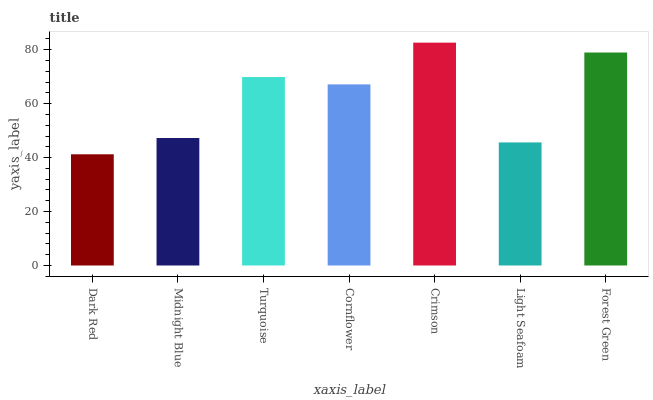Is Dark Red the minimum?
Answer yes or no. Yes. Is Crimson the maximum?
Answer yes or no. Yes. Is Midnight Blue the minimum?
Answer yes or no. No. Is Midnight Blue the maximum?
Answer yes or no. No. Is Midnight Blue greater than Dark Red?
Answer yes or no. Yes. Is Dark Red less than Midnight Blue?
Answer yes or no. Yes. Is Dark Red greater than Midnight Blue?
Answer yes or no. No. Is Midnight Blue less than Dark Red?
Answer yes or no. No. Is Cornflower the high median?
Answer yes or no. Yes. Is Cornflower the low median?
Answer yes or no. Yes. Is Dark Red the high median?
Answer yes or no. No. Is Crimson the low median?
Answer yes or no. No. 